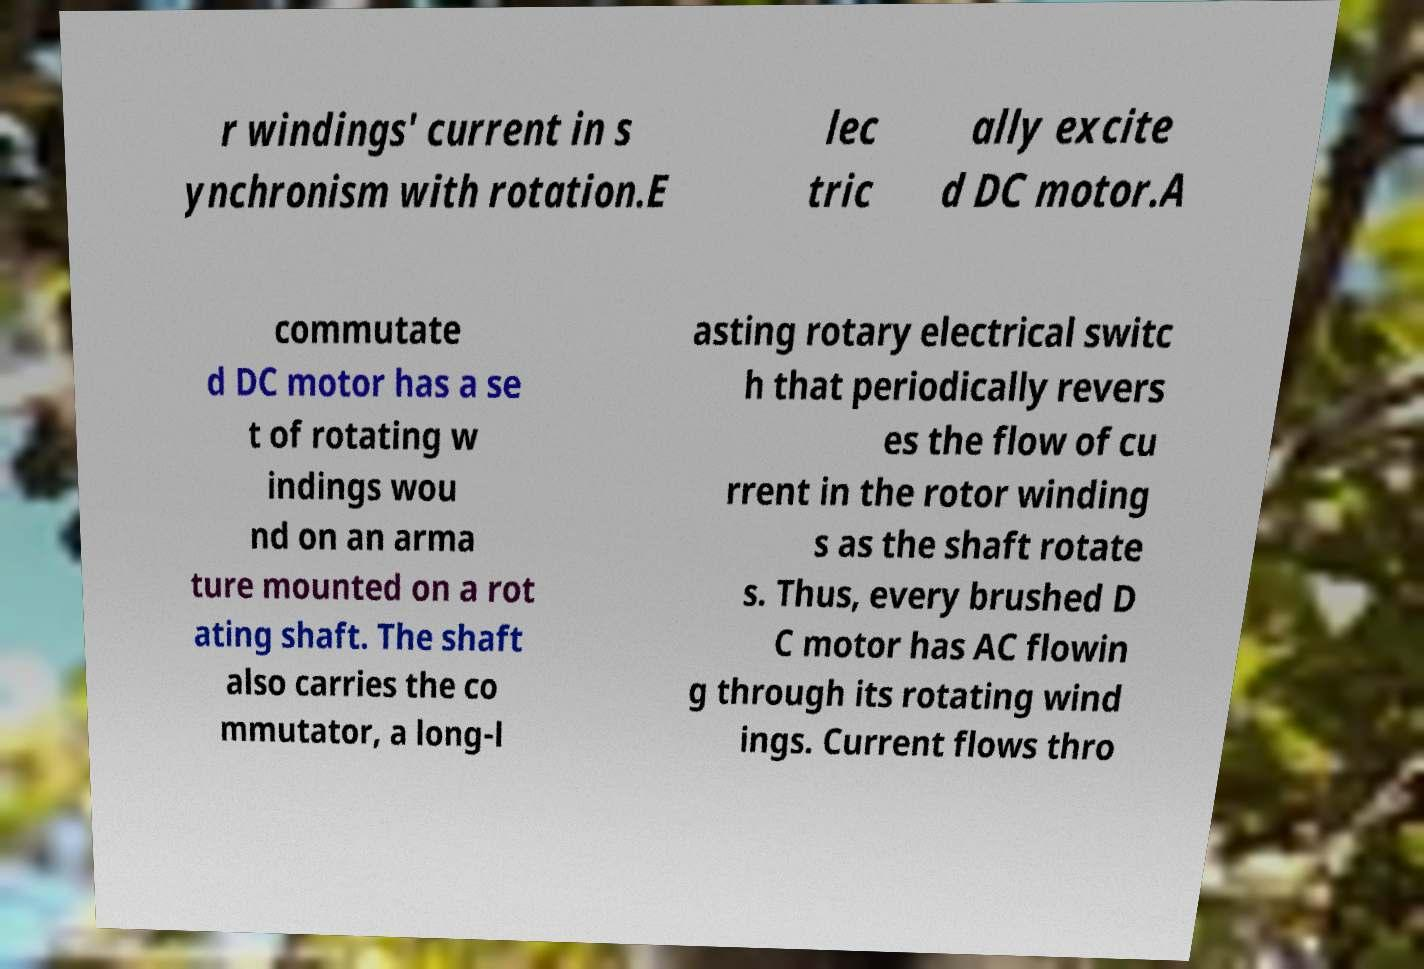Could you assist in decoding the text presented in this image and type it out clearly? r windings' current in s ynchronism with rotation.E lec tric ally excite d DC motor.A commutate d DC motor has a se t of rotating w indings wou nd on an arma ture mounted on a rot ating shaft. The shaft also carries the co mmutator, a long-l asting rotary electrical switc h that periodically revers es the flow of cu rrent in the rotor winding s as the shaft rotate s. Thus, every brushed D C motor has AC flowin g through its rotating wind ings. Current flows thro 